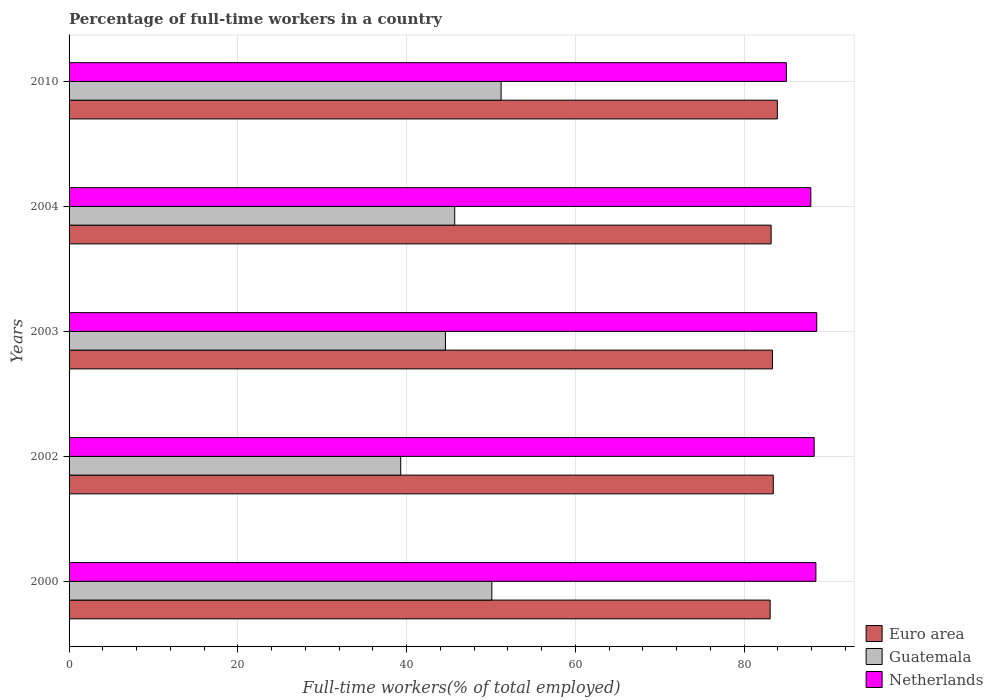Are the number of bars per tick equal to the number of legend labels?
Give a very brief answer. Yes. Are the number of bars on each tick of the Y-axis equal?
Offer a very short reply. Yes. How many bars are there on the 5th tick from the bottom?
Make the answer very short. 3. What is the label of the 5th group of bars from the top?
Make the answer very short. 2000. In how many cases, is the number of bars for a given year not equal to the number of legend labels?
Offer a very short reply. 0. What is the percentage of full-time workers in Guatemala in 2000?
Ensure brevity in your answer.  50.1. Across all years, what is the maximum percentage of full-time workers in Euro area?
Make the answer very short. 83.93. Across all years, what is the minimum percentage of full-time workers in Guatemala?
Provide a succinct answer. 39.3. In which year was the percentage of full-time workers in Netherlands maximum?
Ensure brevity in your answer.  2003. What is the total percentage of full-time workers in Euro area in the graph?
Keep it short and to the point. 417.02. What is the difference between the percentage of full-time workers in Netherlands in 2000 and that in 2002?
Make the answer very short. 0.2. What is the difference between the percentage of full-time workers in Netherlands in 2010 and the percentage of full-time workers in Guatemala in 2000?
Make the answer very short. 34.9. What is the average percentage of full-time workers in Euro area per year?
Provide a short and direct response. 83.4. In the year 2010, what is the difference between the percentage of full-time workers in Guatemala and percentage of full-time workers in Netherlands?
Your answer should be very brief. -33.8. In how many years, is the percentage of full-time workers in Guatemala greater than 12 %?
Your response must be concise. 5. What is the ratio of the percentage of full-time workers in Guatemala in 2004 to that in 2010?
Make the answer very short. 0.89. What is the difference between the highest and the second highest percentage of full-time workers in Euro area?
Provide a succinct answer. 0.48. What is the difference between the highest and the lowest percentage of full-time workers in Euro area?
Your answer should be very brief. 0.85. Is the sum of the percentage of full-time workers in Guatemala in 2000 and 2003 greater than the maximum percentage of full-time workers in Euro area across all years?
Your response must be concise. Yes. What does the 2nd bar from the top in 2003 represents?
Make the answer very short. Guatemala. What does the 1st bar from the bottom in 2000 represents?
Provide a succinct answer. Euro area. Is it the case that in every year, the sum of the percentage of full-time workers in Guatemala and percentage of full-time workers in Netherlands is greater than the percentage of full-time workers in Euro area?
Keep it short and to the point. Yes. Are all the bars in the graph horizontal?
Offer a very short reply. Yes. What is the difference between two consecutive major ticks on the X-axis?
Provide a succinct answer. 20. Are the values on the major ticks of X-axis written in scientific E-notation?
Provide a succinct answer. No. Does the graph contain any zero values?
Give a very brief answer. No. Does the graph contain grids?
Provide a succinct answer. Yes. How many legend labels are there?
Offer a terse response. 3. How are the legend labels stacked?
Provide a short and direct response. Vertical. What is the title of the graph?
Your answer should be very brief. Percentage of full-time workers in a country. What is the label or title of the X-axis?
Your answer should be compact. Full-time workers(% of total employed). What is the Full-time workers(% of total employed) in Euro area in 2000?
Make the answer very short. 83.08. What is the Full-time workers(% of total employed) in Guatemala in 2000?
Your answer should be compact. 50.1. What is the Full-time workers(% of total employed) of Netherlands in 2000?
Give a very brief answer. 88.5. What is the Full-time workers(% of total employed) in Euro area in 2002?
Ensure brevity in your answer.  83.45. What is the Full-time workers(% of total employed) in Guatemala in 2002?
Your response must be concise. 39.3. What is the Full-time workers(% of total employed) in Netherlands in 2002?
Ensure brevity in your answer.  88.3. What is the Full-time workers(% of total employed) in Euro area in 2003?
Provide a short and direct response. 83.36. What is the Full-time workers(% of total employed) in Guatemala in 2003?
Your answer should be compact. 44.6. What is the Full-time workers(% of total employed) in Netherlands in 2003?
Your response must be concise. 88.6. What is the Full-time workers(% of total employed) of Euro area in 2004?
Give a very brief answer. 83.2. What is the Full-time workers(% of total employed) of Guatemala in 2004?
Your answer should be compact. 45.7. What is the Full-time workers(% of total employed) of Netherlands in 2004?
Provide a succinct answer. 87.9. What is the Full-time workers(% of total employed) in Euro area in 2010?
Make the answer very short. 83.93. What is the Full-time workers(% of total employed) in Guatemala in 2010?
Your response must be concise. 51.2. Across all years, what is the maximum Full-time workers(% of total employed) of Euro area?
Make the answer very short. 83.93. Across all years, what is the maximum Full-time workers(% of total employed) of Guatemala?
Keep it short and to the point. 51.2. Across all years, what is the maximum Full-time workers(% of total employed) of Netherlands?
Provide a short and direct response. 88.6. Across all years, what is the minimum Full-time workers(% of total employed) in Euro area?
Ensure brevity in your answer.  83.08. Across all years, what is the minimum Full-time workers(% of total employed) in Guatemala?
Keep it short and to the point. 39.3. Across all years, what is the minimum Full-time workers(% of total employed) in Netherlands?
Make the answer very short. 85. What is the total Full-time workers(% of total employed) of Euro area in the graph?
Offer a terse response. 417.02. What is the total Full-time workers(% of total employed) of Guatemala in the graph?
Give a very brief answer. 230.9. What is the total Full-time workers(% of total employed) in Netherlands in the graph?
Offer a very short reply. 438.3. What is the difference between the Full-time workers(% of total employed) of Euro area in 2000 and that in 2002?
Offer a terse response. -0.37. What is the difference between the Full-time workers(% of total employed) of Netherlands in 2000 and that in 2002?
Provide a succinct answer. 0.2. What is the difference between the Full-time workers(% of total employed) of Euro area in 2000 and that in 2003?
Give a very brief answer. -0.28. What is the difference between the Full-time workers(% of total employed) in Euro area in 2000 and that in 2004?
Your response must be concise. -0.12. What is the difference between the Full-time workers(% of total employed) of Euro area in 2000 and that in 2010?
Offer a terse response. -0.85. What is the difference between the Full-time workers(% of total employed) in Guatemala in 2000 and that in 2010?
Provide a short and direct response. -1.1. What is the difference between the Full-time workers(% of total employed) in Netherlands in 2000 and that in 2010?
Make the answer very short. 3.5. What is the difference between the Full-time workers(% of total employed) of Euro area in 2002 and that in 2003?
Make the answer very short. 0.1. What is the difference between the Full-time workers(% of total employed) in Netherlands in 2002 and that in 2003?
Your response must be concise. -0.3. What is the difference between the Full-time workers(% of total employed) in Euro area in 2002 and that in 2004?
Offer a very short reply. 0.26. What is the difference between the Full-time workers(% of total employed) in Netherlands in 2002 and that in 2004?
Provide a succinct answer. 0.4. What is the difference between the Full-time workers(% of total employed) in Euro area in 2002 and that in 2010?
Your answer should be very brief. -0.48. What is the difference between the Full-time workers(% of total employed) of Euro area in 2003 and that in 2004?
Give a very brief answer. 0.16. What is the difference between the Full-time workers(% of total employed) of Guatemala in 2003 and that in 2004?
Provide a short and direct response. -1.1. What is the difference between the Full-time workers(% of total employed) in Netherlands in 2003 and that in 2004?
Give a very brief answer. 0.7. What is the difference between the Full-time workers(% of total employed) of Euro area in 2003 and that in 2010?
Provide a short and direct response. -0.58. What is the difference between the Full-time workers(% of total employed) in Guatemala in 2003 and that in 2010?
Give a very brief answer. -6.6. What is the difference between the Full-time workers(% of total employed) of Netherlands in 2003 and that in 2010?
Your answer should be very brief. 3.6. What is the difference between the Full-time workers(% of total employed) of Euro area in 2004 and that in 2010?
Make the answer very short. -0.74. What is the difference between the Full-time workers(% of total employed) in Guatemala in 2004 and that in 2010?
Provide a succinct answer. -5.5. What is the difference between the Full-time workers(% of total employed) in Netherlands in 2004 and that in 2010?
Your answer should be compact. 2.9. What is the difference between the Full-time workers(% of total employed) of Euro area in 2000 and the Full-time workers(% of total employed) of Guatemala in 2002?
Make the answer very short. 43.78. What is the difference between the Full-time workers(% of total employed) of Euro area in 2000 and the Full-time workers(% of total employed) of Netherlands in 2002?
Provide a succinct answer. -5.22. What is the difference between the Full-time workers(% of total employed) in Guatemala in 2000 and the Full-time workers(% of total employed) in Netherlands in 2002?
Offer a terse response. -38.2. What is the difference between the Full-time workers(% of total employed) in Euro area in 2000 and the Full-time workers(% of total employed) in Guatemala in 2003?
Keep it short and to the point. 38.48. What is the difference between the Full-time workers(% of total employed) of Euro area in 2000 and the Full-time workers(% of total employed) of Netherlands in 2003?
Provide a succinct answer. -5.52. What is the difference between the Full-time workers(% of total employed) in Guatemala in 2000 and the Full-time workers(% of total employed) in Netherlands in 2003?
Provide a succinct answer. -38.5. What is the difference between the Full-time workers(% of total employed) of Euro area in 2000 and the Full-time workers(% of total employed) of Guatemala in 2004?
Make the answer very short. 37.38. What is the difference between the Full-time workers(% of total employed) of Euro area in 2000 and the Full-time workers(% of total employed) of Netherlands in 2004?
Provide a succinct answer. -4.82. What is the difference between the Full-time workers(% of total employed) in Guatemala in 2000 and the Full-time workers(% of total employed) in Netherlands in 2004?
Your response must be concise. -37.8. What is the difference between the Full-time workers(% of total employed) of Euro area in 2000 and the Full-time workers(% of total employed) of Guatemala in 2010?
Your answer should be very brief. 31.88. What is the difference between the Full-time workers(% of total employed) in Euro area in 2000 and the Full-time workers(% of total employed) in Netherlands in 2010?
Offer a terse response. -1.92. What is the difference between the Full-time workers(% of total employed) of Guatemala in 2000 and the Full-time workers(% of total employed) of Netherlands in 2010?
Your answer should be compact. -34.9. What is the difference between the Full-time workers(% of total employed) in Euro area in 2002 and the Full-time workers(% of total employed) in Guatemala in 2003?
Offer a very short reply. 38.85. What is the difference between the Full-time workers(% of total employed) of Euro area in 2002 and the Full-time workers(% of total employed) of Netherlands in 2003?
Offer a very short reply. -5.15. What is the difference between the Full-time workers(% of total employed) in Guatemala in 2002 and the Full-time workers(% of total employed) in Netherlands in 2003?
Keep it short and to the point. -49.3. What is the difference between the Full-time workers(% of total employed) in Euro area in 2002 and the Full-time workers(% of total employed) in Guatemala in 2004?
Give a very brief answer. 37.75. What is the difference between the Full-time workers(% of total employed) of Euro area in 2002 and the Full-time workers(% of total employed) of Netherlands in 2004?
Offer a terse response. -4.45. What is the difference between the Full-time workers(% of total employed) of Guatemala in 2002 and the Full-time workers(% of total employed) of Netherlands in 2004?
Give a very brief answer. -48.6. What is the difference between the Full-time workers(% of total employed) of Euro area in 2002 and the Full-time workers(% of total employed) of Guatemala in 2010?
Keep it short and to the point. 32.25. What is the difference between the Full-time workers(% of total employed) in Euro area in 2002 and the Full-time workers(% of total employed) in Netherlands in 2010?
Provide a succinct answer. -1.55. What is the difference between the Full-time workers(% of total employed) of Guatemala in 2002 and the Full-time workers(% of total employed) of Netherlands in 2010?
Offer a very short reply. -45.7. What is the difference between the Full-time workers(% of total employed) in Euro area in 2003 and the Full-time workers(% of total employed) in Guatemala in 2004?
Your response must be concise. 37.66. What is the difference between the Full-time workers(% of total employed) in Euro area in 2003 and the Full-time workers(% of total employed) in Netherlands in 2004?
Ensure brevity in your answer.  -4.54. What is the difference between the Full-time workers(% of total employed) in Guatemala in 2003 and the Full-time workers(% of total employed) in Netherlands in 2004?
Ensure brevity in your answer.  -43.3. What is the difference between the Full-time workers(% of total employed) of Euro area in 2003 and the Full-time workers(% of total employed) of Guatemala in 2010?
Your answer should be compact. 32.16. What is the difference between the Full-time workers(% of total employed) of Euro area in 2003 and the Full-time workers(% of total employed) of Netherlands in 2010?
Offer a terse response. -1.64. What is the difference between the Full-time workers(% of total employed) in Guatemala in 2003 and the Full-time workers(% of total employed) in Netherlands in 2010?
Keep it short and to the point. -40.4. What is the difference between the Full-time workers(% of total employed) in Euro area in 2004 and the Full-time workers(% of total employed) in Guatemala in 2010?
Make the answer very short. 32. What is the difference between the Full-time workers(% of total employed) in Euro area in 2004 and the Full-time workers(% of total employed) in Netherlands in 2010?
Keep it short and to the point. -1.8. What is the difference between the Full-time workers(% of total employed) in Guatemala in 2004 and the Full-time workers(% of total employed) in Netherlands in 2010?
Offer a terse response. -39.3. What is the average Full-time workers(% of total employed) of Euro area per year?
Your response must be concise. 83.4. What is the average Full-time workers(% of total employed) of Guatemala per year?
Make the answer very short. 46.18. What is the average Full-time workers(% of total employed) of Netherlands per year?
Your response must be concise. 87.66. In the year 2000, what is the difference between the Full-time workers(% of total employed) in Euro area and Full-time workers(% of total employed) in Guatemala?
Provide a short and direct response. 32.98. In the year 2000, what is the difference between the Full-time workers(% of total employed) of Euro area and Full-time workers(% of total employed) of Netherlands?
Your response must be concise. -5.42. In the year 2000, what is the difference between the Full-time workers(% of total employed) in Guatemala and Full-time workers(% of total employed) in Netherlands?
Offer a terse response. -38.4. In the year 2002, what is the difference between the Full-time workers(% of total employed) of Euro area and Full-time workers(% of total employed) of Guatemala?
Offer a very short reply. 44.15. In the year 2002, what is the difference between the Full-time workers(% of total employed) of Euro area and Full-time workers(% of total employed) of Netherlands?
Your answer should be compact. -4.85. In the year 2002, what is the difference between the Full-time workers(% of total employed) of Guatemala and Full-time workers(% of total employed) of Netherlands?
Keep it short and to the point. -49. In the year 2003, what is the difference between the Full-time workers(% of total employed) in Euro area and Full-time workers(% of total employed) in Guatemala?
Your answer should be compact. 38.76. In the year 2003, what is the difference between the Full-time workers(% of total employed) in Euro area and Full-time workers(% of total employed) in Netherlands?
Your response must be concise. -5.24. In the year 2003, what is the difference between the Full-time workers(% of total employed) of Guatemala and Full-time workers(% of total employed) of Netherlands?
Offer a terse response. -44. In the year 2004, what is the difference between the Full-time workers(% of total employed) in Euro area and Full-time workers(% of total employed) in Guatemala?
Offer a terse response. 37.5. In the year 2004, what is the difference between the Full-time workers(% of total employed) in Euro area and Full-time workers(% of total employed) in Netherlands?
Your answer should be very brief. -4.7. In the year 2004, what is the difference between the Full-time workers(% of total employed) in Guatemala and Full-time workers(% of total employed) in Netherlands?
Keep it short and to the point. -42.2. In the year 2010, what is the difference between the Full-time workers(% of total employed) of Euro area and Full-time workers(% of total employed) of Guatemala?
Ensure brevity in your answer.  32.73. In the year 2010, what is the difference between the Full-time workers(% of total employed) of Euro area and Full-time workers(% of total employed) of Netherlands?
Keep it short and to the point. -1.07. In the year 2010, what is the difference between the Full-time workers(% of total employed) of Guatemala and Full-time workers(% of total employed) of Netherlands?
Keep it short and to the point. -33.8. What is the ratio of the Full-time workers(% of total employed) of Euro area in 2000 to that in 2002?
Provide a short and direct response. 1. What is the ratio of the Full-time workers(% of total employed) in Guatemala in 2000 to that in 2002?
Ensure brevity in your answer.  1.27. What is the ratio of the Full-time workers(% of total employed) of Netherlands in 2000 to that in 2002?
Provide a short and direct response. 1. What is the ratio of the Full-time workers(% of total employed) in Guatemala in 2000 to that in 2003?
Provide a succinct answer. 1.12. What is the ratio of the Full-time workers(% of total employed) in Netherlands in 2000 to that in 2003?
Provide a short and direct response. 1. What is the ratio of the Full-time workers(% of total employed) in Euro area in 2000 to that in 2004?
Your answer should be compact. 1. What is the ratio of the Full-time workers(% of total employed) in Guatemala in 2000 to that in 2004?
Give a very brief answer. 1.1. What is the ratio of the Full-time workers(% of total employed) in Netherlands in 2000 to that in 2004?
Make the answer very short. 1.01. What is the ratio of the Full-time workers(% of total employed) in Euro area in 2000 to that in 2010?
Provide a short and direct response. 0.99. What is the ratio of the Full-time workers(% of total employed) of Guatemala in 2000 to that in 2010?
Give a very brief answer. 0.98. What is the ratio of the Full-time workers(% of total employed) in Netherlands in 2000 to that in 2010?
Offer a terse response. 1.04. What is the ratio of the Full-time workers(% of total employed) in Guatemala in 2002 to that in 2003?
Your answer should be compact. 0.88. What is the ratio of the Full-time workers(% of total employed) in Euro area in 2002 to that in 2004?
Ensure brevity in your answer.  1. What is the ratio of the Full-time workers(% of total employed) of Guatemala in 2002 to that in 2004?
Ensure brevity in your answer.  0.86. What is the ratio of the Full-time workers(% of total employed) of Netherlands in 2002 to that in 2004?
Make the answer very short. 1. What is the ratio of the Full-time workers(% of total employed) in Euro area in 2002 to that in 2010?
Keep it short and to the point. 0.99. What is the ratio of the Full-time workers(% of total employed) in Guatemala in 2002 to that in 2010?
Your answer should be compact. 0.77. What is the ratio of the Full-time workers(% of total employed) in Netherlands in 2002 to that in 2010?
Offer a very short reply. 1.04. What is the ratio of the Full-time workers(% of total employed) of Euro area in 2003 to that in 2004?
Offer a terse response. 1. What is the ratio of the Full-time workers(% of total employed) of Guatemala in 2003 to that in 2004?
Provide a short and direct response. 0.98. What is the ratio of the Full-time workers(% of total employed) of Guatemala in 2003 to that in 2010?
Keep it short and to the point. 0.87. What is the ratio of the Full-time workers(% of total employed) in Netherlands in 2003 to that in 2010?
Keep it short and to the point. 1.04. What is the ratio of the Full-time workers(% of total employed) of Guatemala in 2004 to that in 2010?
Offer a very short reply. 0.89. What is the ratio of the Full-time workers(% of total employed) of Netherlands in 2004 to that in 2010?
Provide a short and direct response. 1.03. What is the difference between the highest and the second highest Full-time workers(% of total employed) in Euro area?
Your answer should be very brief. 0.48. What is the difference between the highest and the second highest Full-time workers(% of total employed) of Netherlands?
Give a very brief answer. 0.1. What is the difference between the highest and the lowest Full-time workers(% of total employed) of Euro area?
Ensure brevity in your answer.  0.85. What is the difference between the highest and the lowest Full-time workers(% of total employed) in Guatemala?
Ensure brevity in your answer.  11.9. What is the difference between the highest and the lowest Full-time workers(% of total employed) in Netherlands?
Ensure brevity in your answer.  3.6. 